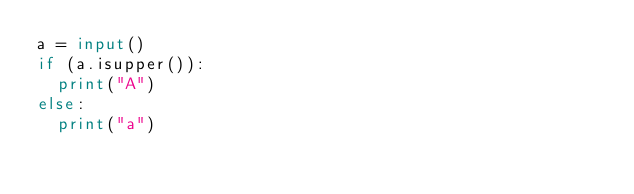Convert code to text. <code><loc_0><loc_0><loc_500><loc_500><_Python_>a = input()
if (a.isupper()):
  print("A")
else:
  print("a")</code> 